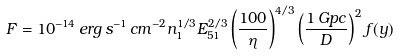Convert formula to latex. <formula><loc_0><loc_0><loc_500><loc_500>F = 1 0 ^ { - 1 4 } \, e r g \, s ^ { - 1 } \, c m ^ { - 2 } n _ { 1 } ^ { 1 / 3 } E _ { 5 1 } ^ { 2 / 3 } \left ( \frac { 1 0 0 } { \eta } \right ) ^ { 4 / 3 } \left ( \frac { 1 \, G p c } { D } \right ) ^ { 2 } f ( y )</formula> 